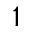<formula> <loc_0><loc_0><loc_500><loc_500>^ { 1 }</formula> 